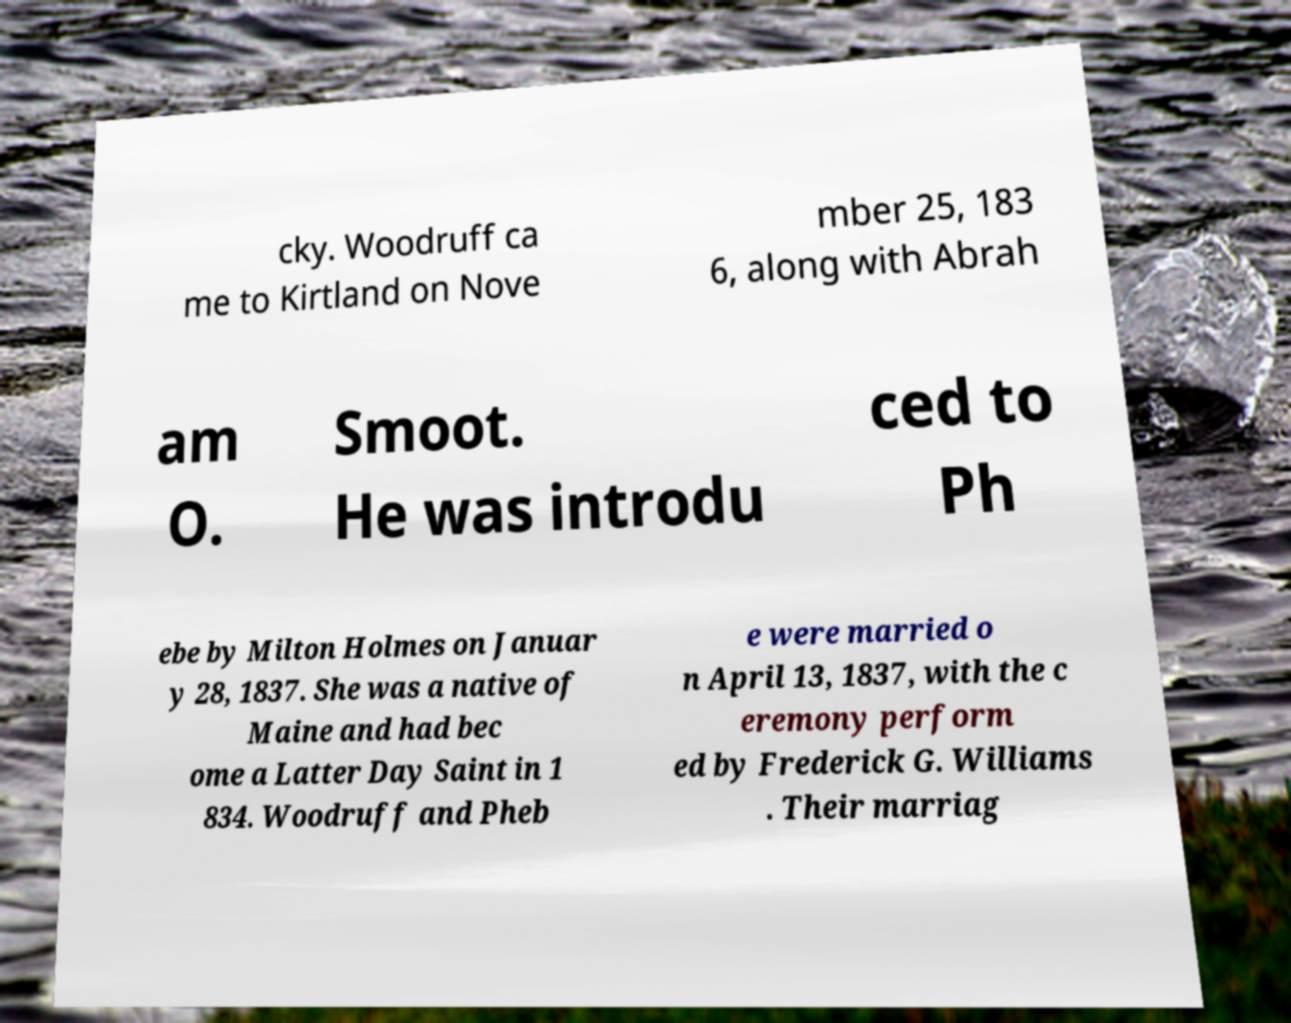There's text embedded in this image that I need extracted. Can you transcribe it verbatim? cky. Woodruff ca me to Kirtland on Nove mber 25, 183 6, along with Abrah am O. Smoot. He was introdu ced to Ph ebe by Milton Holmes on Januar y 28, 1837. She was a native of Maine and had bec ome a Latter Day Saint in 1 834. Woodruff and Pheb e were married o n April 13, 1837, with the c eremony perform ed by Frederick G. Williams . Their marriag 